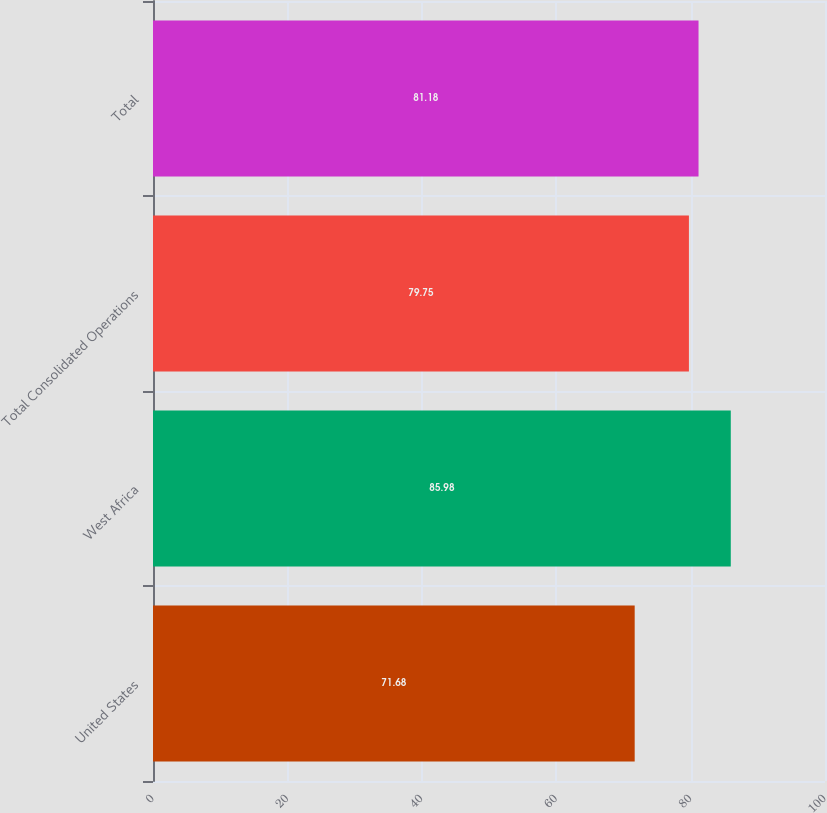Convert chart to OTSL. <chart><loc_0><loc_0><loc_500><loc_500><bar_chart><fcel>United States<fcel>West Africa<fcel>Total Consolidated Operations<fcel>Total<nl><fcel>71.68<fcel>85.98<fcel>79.75<fcel>81.18<nl></chart> 